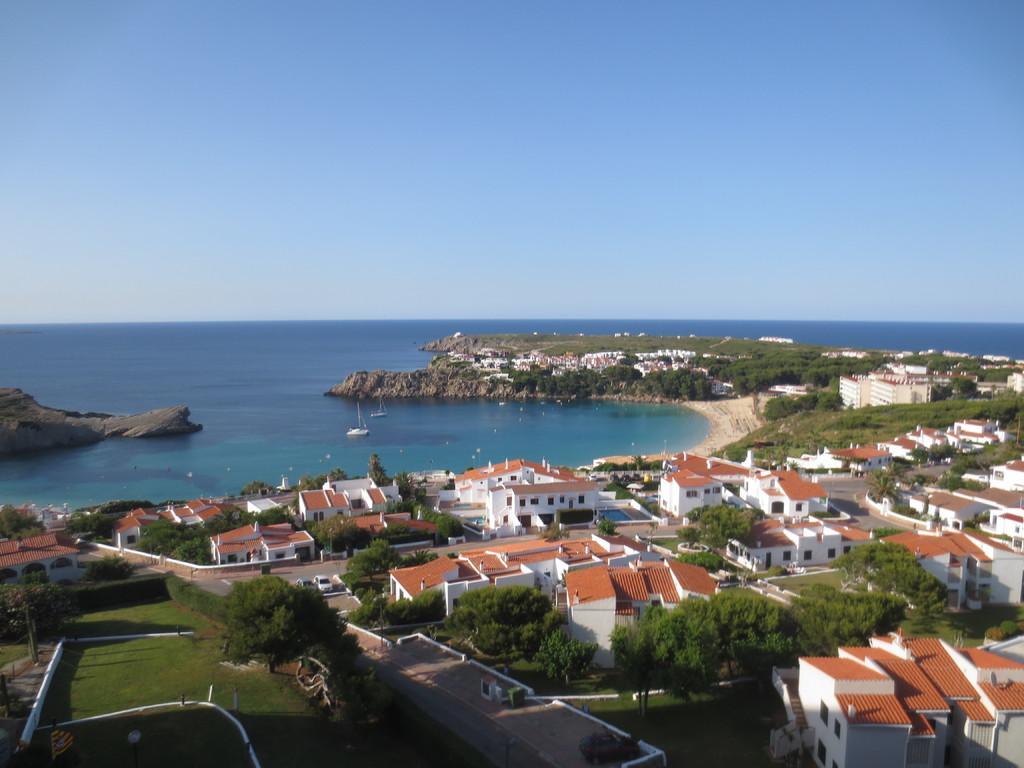Please provide a concise description of this image. This is an aerial view and here we can see houses, trees, roads and we can see some vehicles and there are boats on the water. At the top, there is sky. 